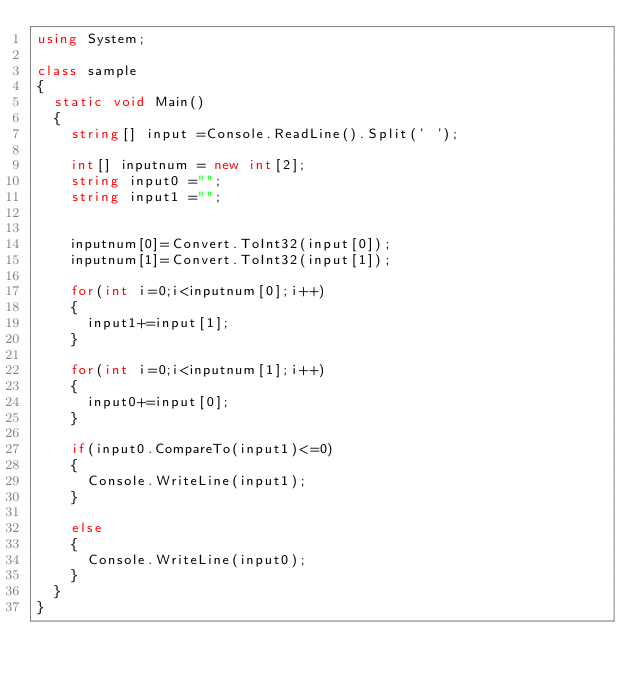Convert code to text. <code><loc_0><loc_0><loc_500><loc_500><_C#_>using System;

class sample
{
	static void Main()
	{
		string[] input =Console.ReadLine().Split(' ');

		int[] inputnum = new int[2];
		string input0 ="";
		string input1 ="";


		inputnum[0]=Convert.ToInt32(input[0]);
		inputnum[1]=Convert.ToInt32(input[1]);

		for(int i=0;i<inputnum[0];i++)
		{
			input1+=input[1];
		}

		for(int i=0;i<inputnum[1];i++)
		{
			input0+=input[0];
		}

		if(input0.CompareTo(input1)<=0)
		{
			Console.WriteLine(input1);
		}

		else
		{
			Console.WriteLine(input0);
		}
	}
}



</code> 